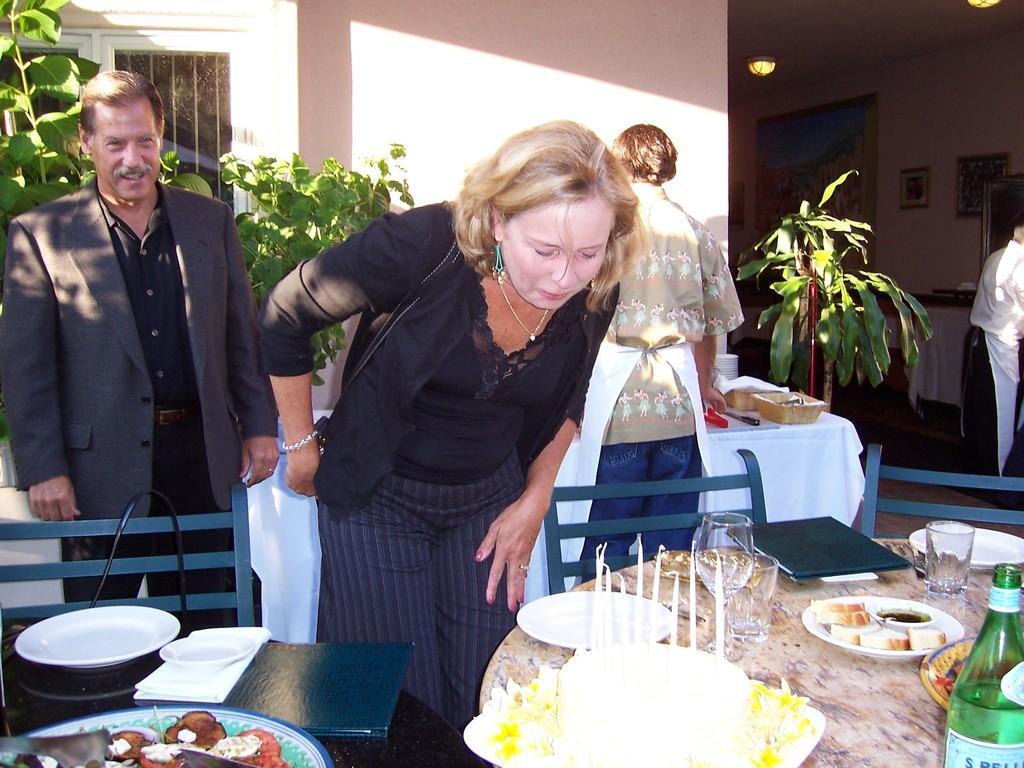Can you describe this image briefly? In the middle of the image few people are standing. Bottom right side of the image there is a table, On the table there are some candles, glass, plate, bread, bottle, saucer. Top right side of the image there is a wall, On the wall there are some frames. In the middle of the image there is a plant. Bottom right side of the image there is a chair and table. Top left side of the image there is a window. 